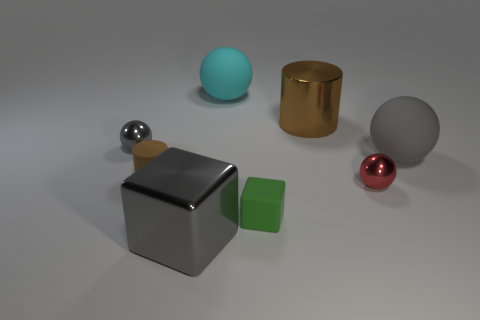Is the size of the matte cylinder the same as the gray shiny object that is behind the tiny brown thing?
Provide a short and direct response. Yes. There is a big gray object behind the tiny brown object; what is its shape?
Make the answer very short. Sphere. There is a small shiny ball left of the brown thing that is right of the tiny green block; is there a large gray ball that is behind it?
Your answer should be very brief. No. There is a large brown thing that is the same shape as the tiny brown matte object; what is its material?
Keep it short and to the point. Metal. What number of balls are tiny red shiny objects or brown things?
Your answer should be compact. 1. Is the size of the gray metal object that is behind the small red thing the same as the cylinder on the right side of the tiny brown matte thing?
Your answer should be very brief. No. The brown cylinder on the right side of the large gray thing that is to the left of the small green thing is made of what material?
Offer a terse response. Metal. Is the number of rubber cylinders that are to the left of the green matte thing less than the number of large metal things?
Give a very brief answer. Yes. The green thing that is made of the same material as the small brown cylinder is what shape?
Your answer should be very brief. Cube. How many other things are there of the same shape as the cyan object?
Keep it short and to the point. 3. 